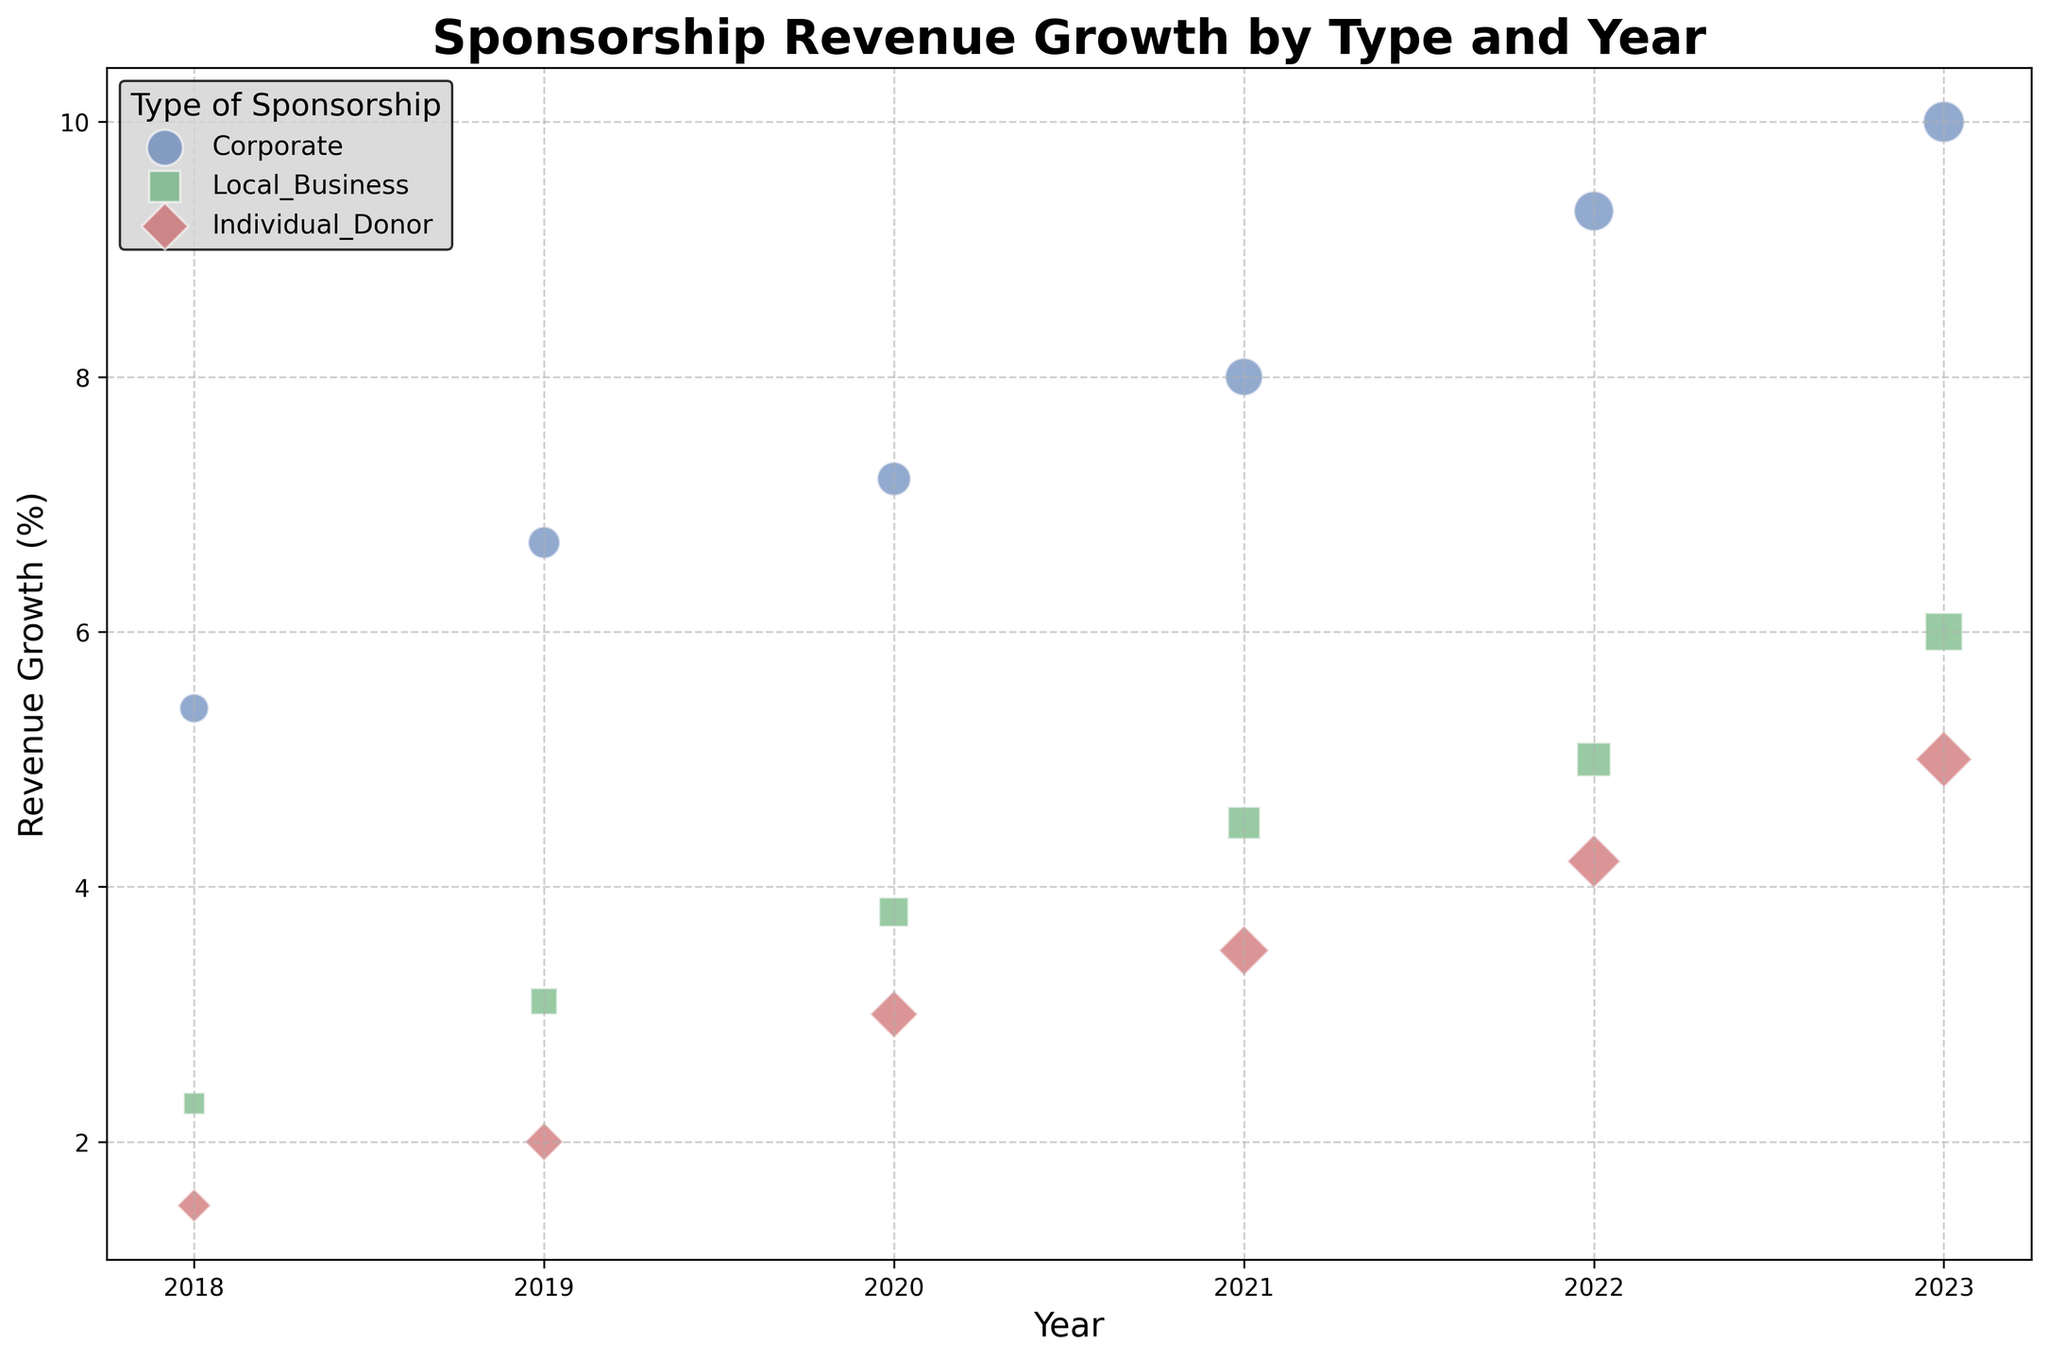Which type of sponsorship had the highest revenue growth in 2023? Looking at the scatter points for the year 2023, the Corporate sponsorship type had the highest revenue growth, represented by the highest bubble on the y-axis.
Answer: Corporate How did the number of sponsorship deals with local businesses change from 2018 to 2023? By comparing the size of the green bubbles representing Local Business across the years, the number increased from 8 deals in 2018 to 25 deals in 2023.
Answer: Increased Compare the revenue growth of Individual Donors in 2020 and 2021. Which year had higher growth, and by how much? The red bubbles for Individual Donor show a growth of 3.0% in 2020 and 3.5% in 2021. 2021 had a higher growth by 0.5%.
Answer: 2021, by 0.5% Which type of sponsorship shows a consistent increase in revenue growth each year from 2018 to 2023? By following the trajectory of each color-coded sponsorship type, the blue bubbles for Corporate sponsorship show a consistent increase in revenue growth each year.
Answer: Corporate What is the average revenue growth of Individual Donors from 2019 to 2021? Summing up the red bubbles’ revenue growth values for the years 2019 (2.0), 2020 (3.0), and 2021 (3.5), the total is 8.5. Dividing by 3 gives an average of 2.83.
Answer: 2.83 Which year had the smallest revenue growth for Local Business sponsorships? The green bubbles showing Local Business sponsorship reveal the smallest revenue growth in 2018 with 2.3%.
Answer: 2018 In which year did the number of Corporate sponsorship deals surpass 20? By checking the size of the blue bubbles, 2020 is the year when Corporate deals first crossed the 20 mark, with exactly 20 deals.
Answer: 2020 How does the revenue growth of Corporate sponsorship in 2023 compare to 2018? Observing the blue bubbles, the growth increased from 5.4% in 2018 to 10.0% in 2023. This is an increase of 4.6%.
Answer: Increased by 4.6% What is the total number of sponsorship deals from Local Businesses in 2019 and 2023? Adding the green bubbles' counts for 2019 (12) and 2023 (25), the total is 37.
Answer: 37 